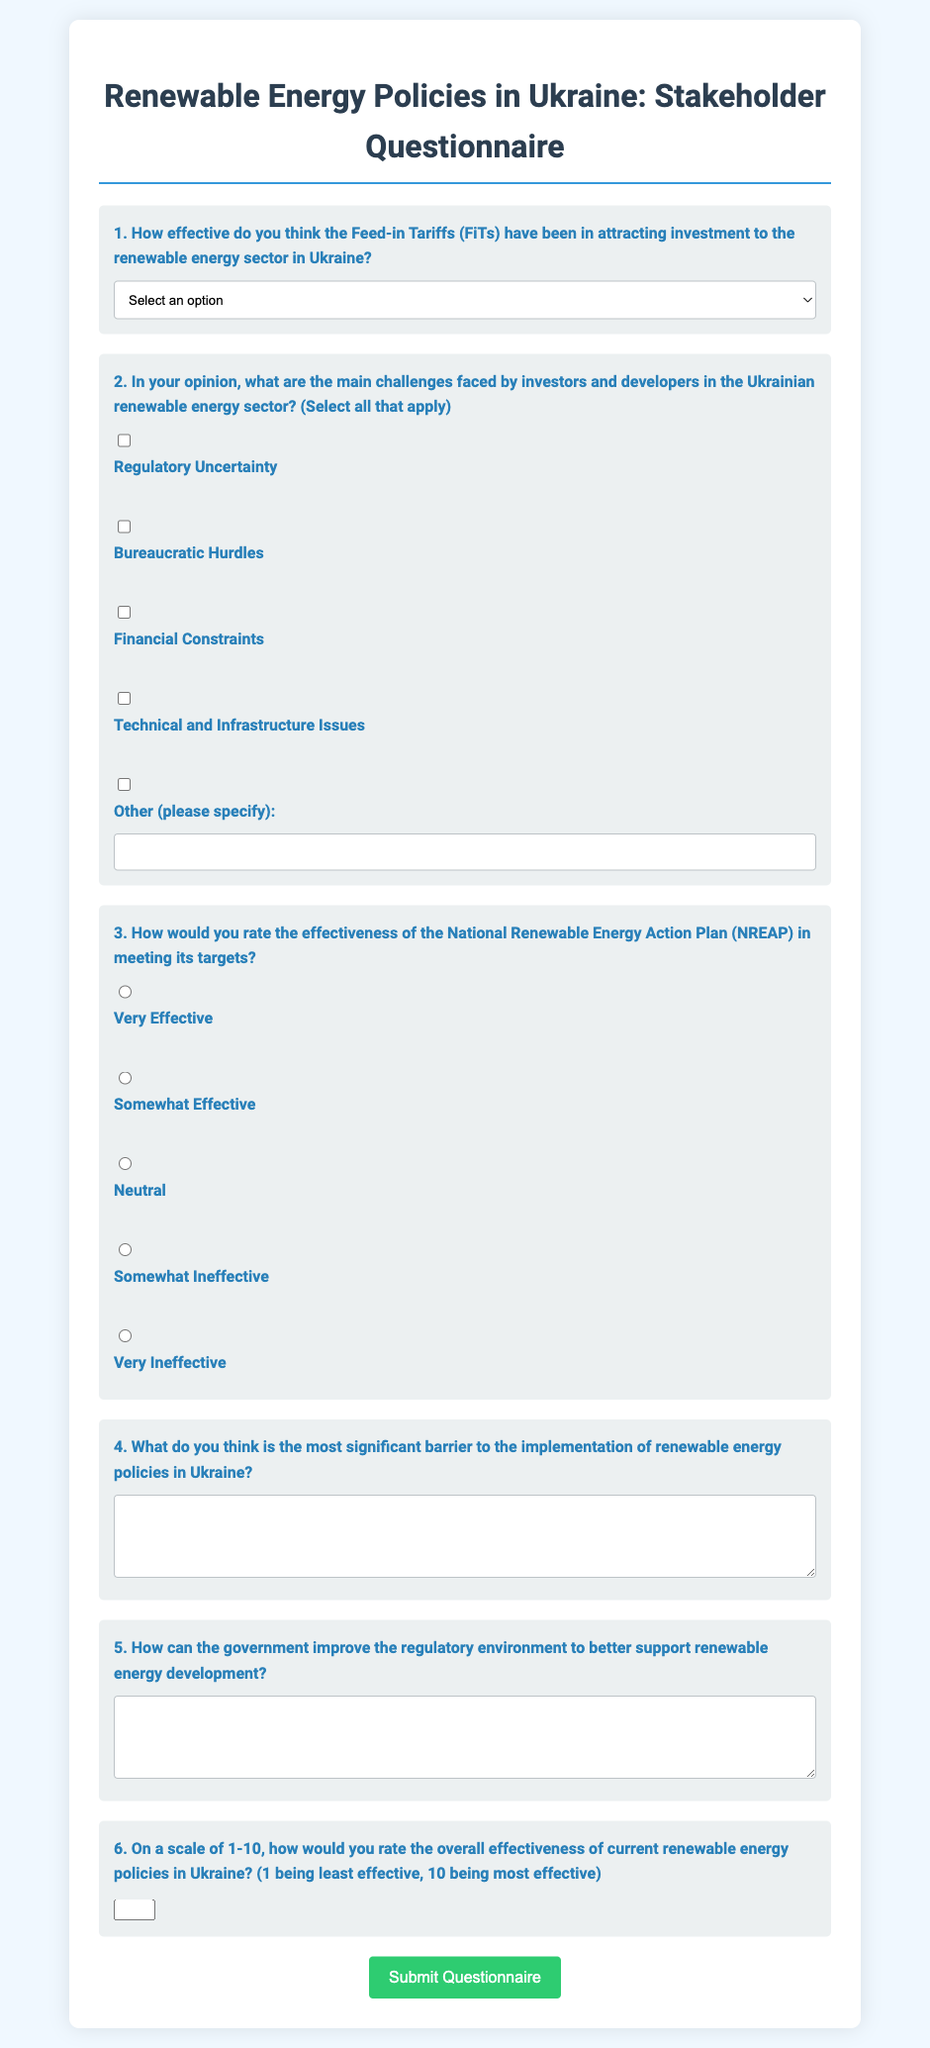What is the title of the questionnaire? The title of the questionnaire is provided at the beginning of the document.
Answer: Renewable Energy Policies in Ukraine: Stakeholder Questionnaire How many effectiveness options are provided for the Feed-in Tariffs? The document specifies options for effectiveness assessment regarding Feed-in Tariffs.
Answer: Five options What is the first challenge listed for Ukrainian renewable energy investors? The challenges faced by investors are enumerated in a specific order; the first one is mentioned first.
Answer: Regulatory Uncertainty Which government document's effectiveness is being rated in the questionnaire? The questionnaire explicitly inquires about the effectiveness of a specific national action plan related to renewable energy.
Answer: National Renewable Energy Action Plan (NREAP) What type of question is number 4 in the questionnaire? Question number 4 focuses on identifying a significant barrier to implementation, which requires a descriptive answer.
Answer: Open-ended question On a scale of 1-10, what does the questionnaire ask respondents to rate? The questionnaire requests respondents to evaluate the effectiveness of current renewable energy policies using a numerical scale.
Answer: Overall effectiveness What is the required input type for the rating question on renewable energy policy effectiveness? The document specifies how the respondents should provide their ratings in the respective section.
Answer: Number How is the background of the questionnaire styled? The design characteristics of the document, particularly in terms of color and layout, are described in the styling.
Answer: Light blue background and white container 